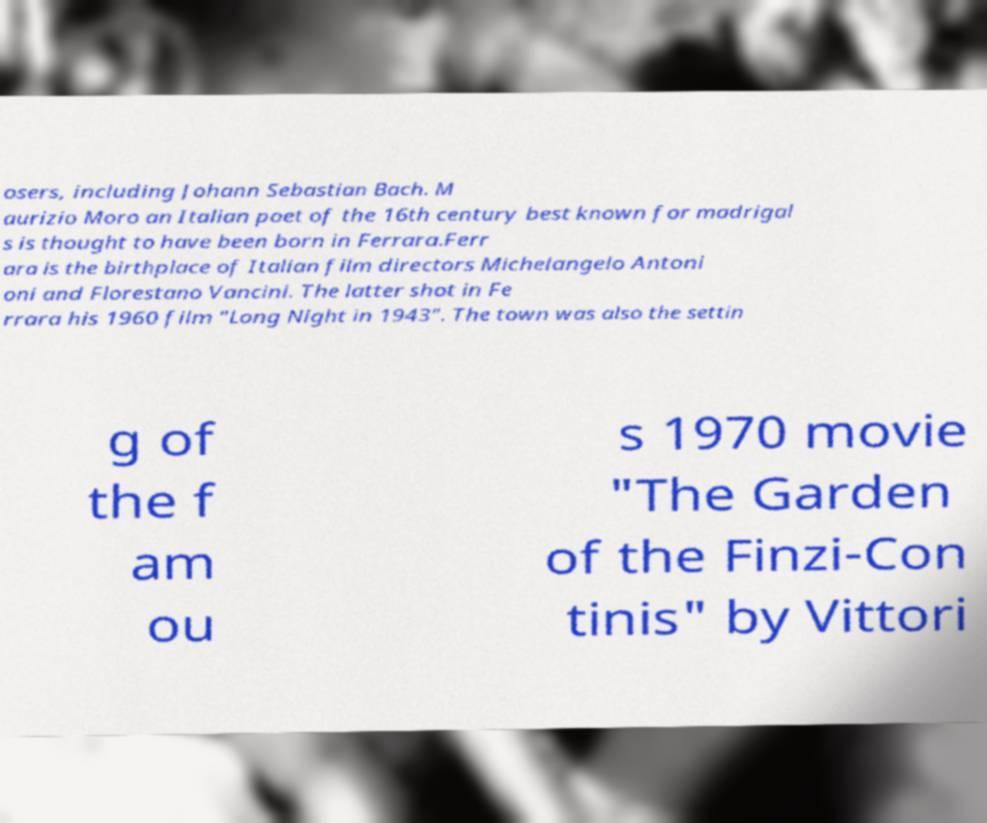Please identify and transcribe the text found in this image. osers, including Johann Sebastian Bach. M aurizio Moro an Italian poet of the 16th century best known for madrigal s is thought to have been born in Ferrara.Ferr ara is the birthplace of Italian film directors Michelangelo Antoni oni and Florestano Vancini. The latter shot in Fe rrara his 1960 film "Long Night in 1943". The town was also the settin g of the f am ou s 1970 movie "The Garden of the Finzi-Con tinis" by Vittori 